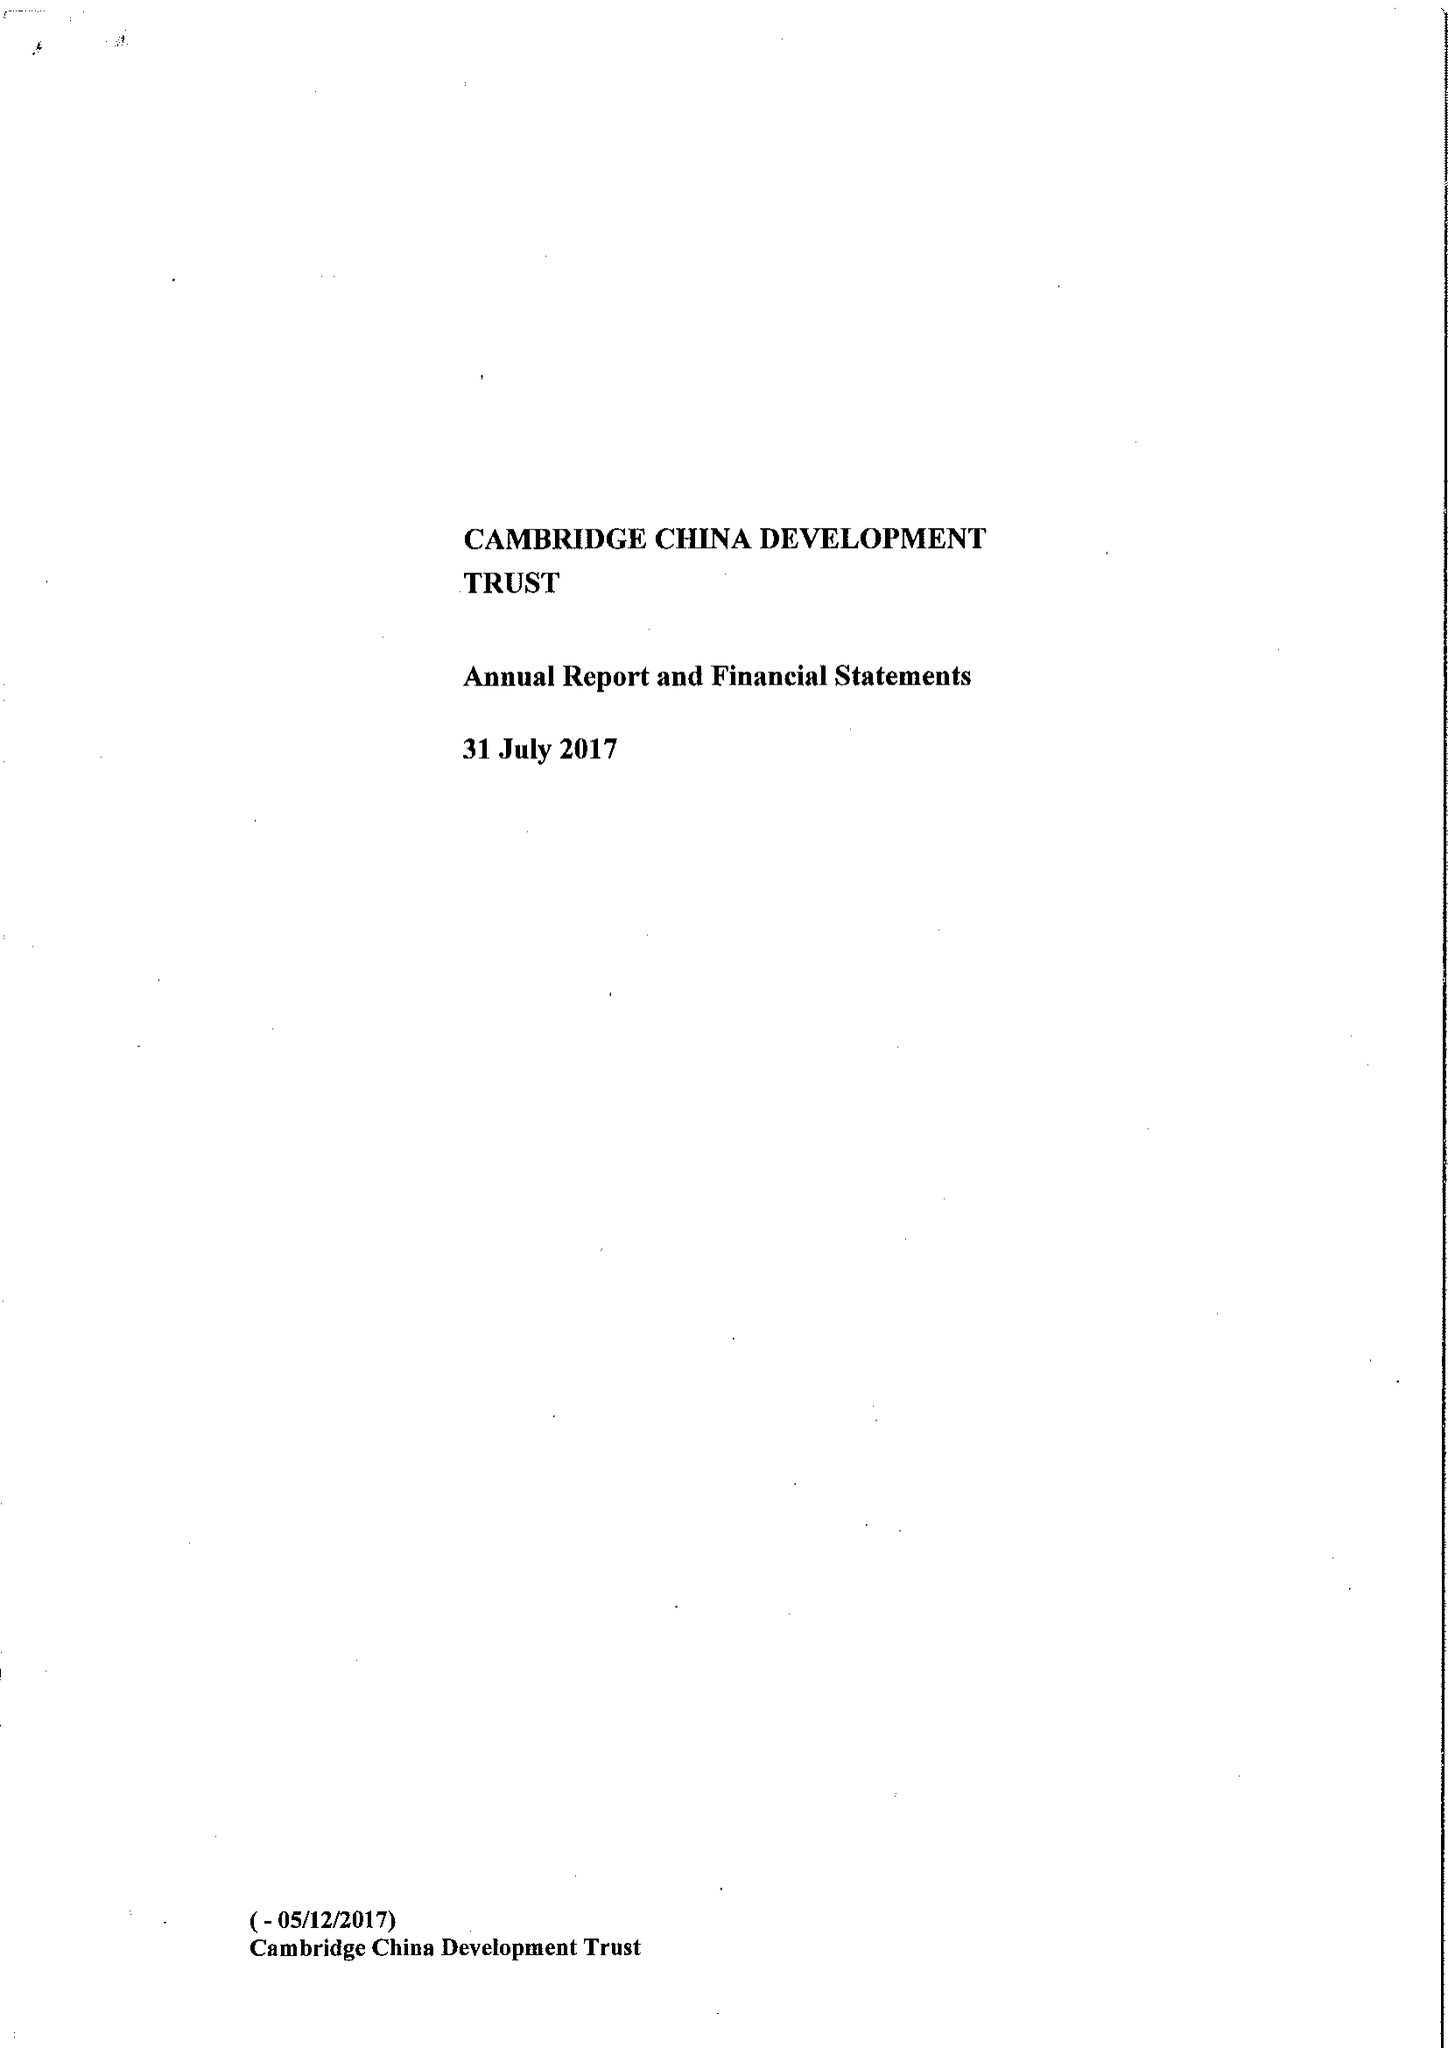What is the value for the charity_name?
Answer the question using a single word or phrase. The Cambridge China Development Trust 